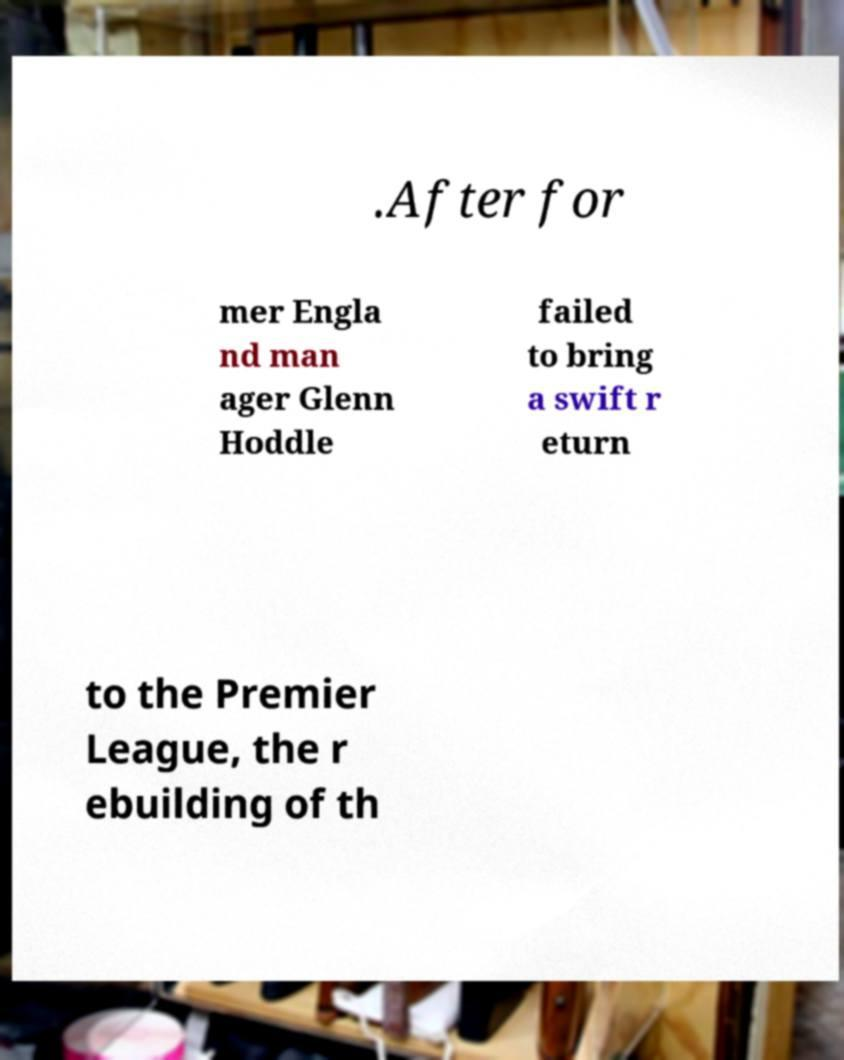Could you extract and type out the text from this image? .After for mer Engla nd man ager Glenn Hoddle failed to bring a swift r eturn to the Premier League, the r ebuilding of th 